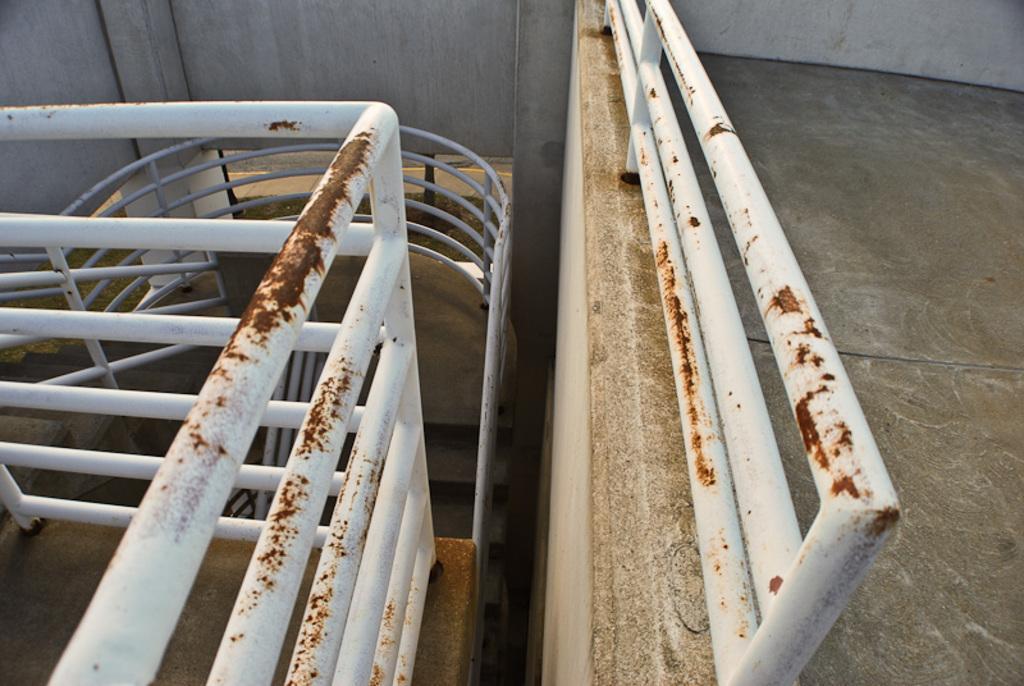Please provide a concise description of this image. In this image we can see railings, stairs, also we can see the wall. 